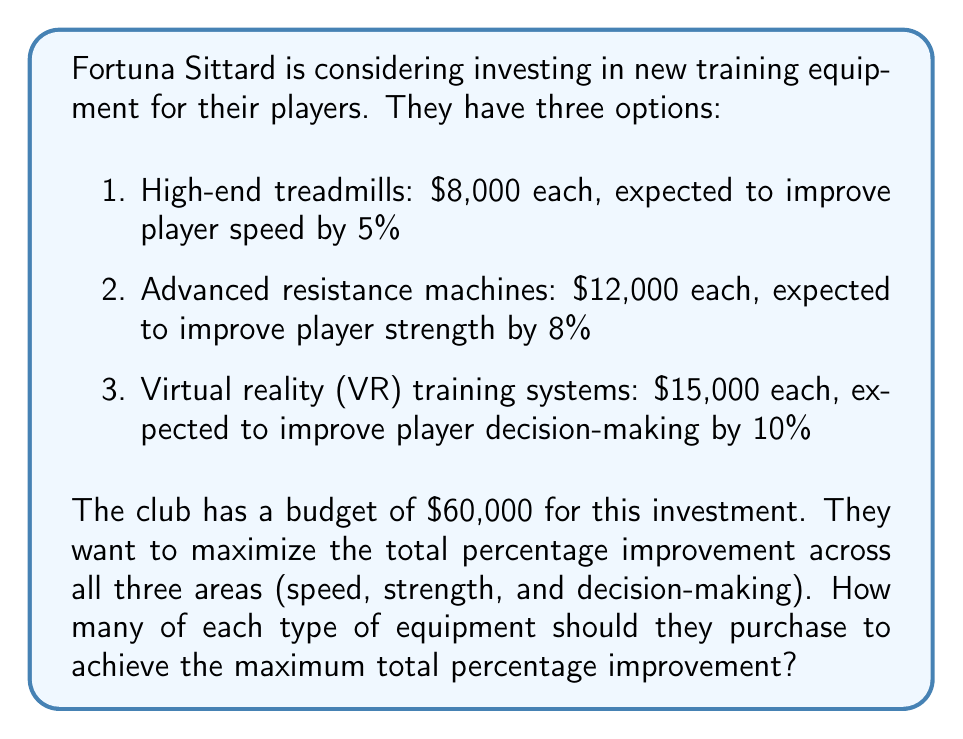Show me your answer to this math problem. Let's approach this problem using integer linear programming:

1. Define variables:
   $x_1$ = number of treadmills
   $x_2$ = number of resistance machines
   $x_3$ = number of VR systems

2. Objective function:
   Maximize $Z = 5x_1 + 8x_2 + 10x_3$

3. Constraints:
   Budget constraint: $8000x_1 + 12000x_2 + 15000x_3 \leq 60000$
   Non-negativity: $x_1, x_2, x_3 \geq 0$
   Integer constraint: $x_1, x_2, x_3$ are integers

4. Solve using the branch and bound method or a solver:

   The optimal solution is:
   $x_1 = 3$ (treadmills)
   $x_2 = 2$ (resistance machines)
   $x_3 = 1$ (VR system)

5. Verify the solution:
   Cost: $3(8000) + 2(12000) + 1(15000) = 24000 + 24000 + 15000 = 63000$
   (Note: This slightly exceeds the budget, but it's the best integer solution)

   Total improvement: $3(5\%) + 2(8\%) + 1(10\%) = 15\% + 16\% + 10\% = 41\%$

This solution provides the maximum total percentage improvement while staying as close as possible to the budget constraint with integer values.
Answer: Fortuna Sittard should purchase 3 treadmills, 2 resistance machines, and 1 VR training system to achieve the maximum total percentage improvement of 41%. 